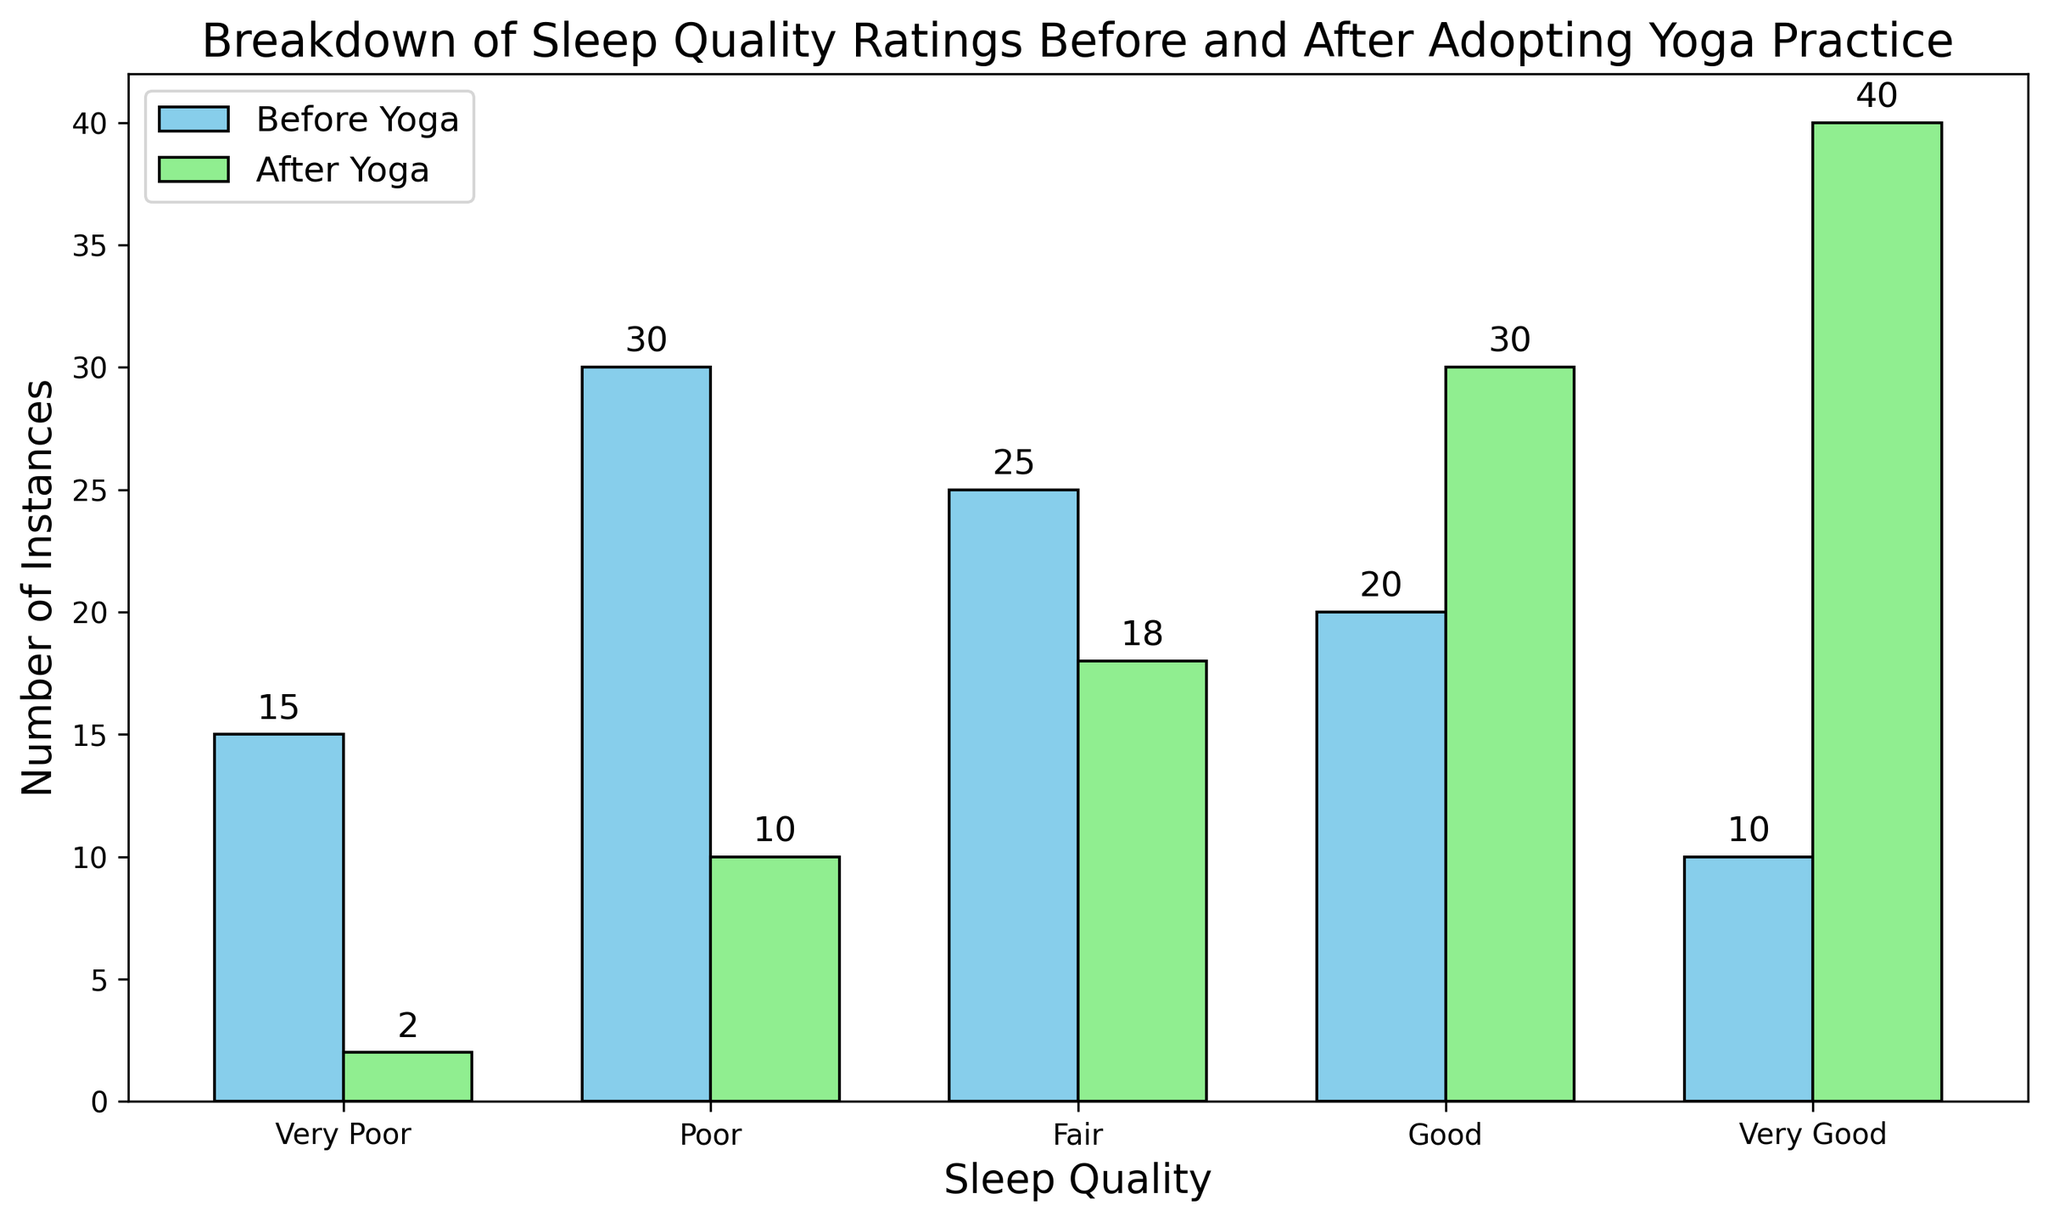What is the total number of instances for "Very Poor" sleep quality before and after adopting yoga? Add the instances for "Very Poor" sleep quality before and after yoga. Before yoga: 15, After yoga: 2, so 15 + 2 = 17
Answer: 17 Which sleep quality rating saw the highest increase in the number of instances after adopting yoga? Compare the increase in each sleep quality rating from before to after practicing yoga. "Very Poor" decreased from 15 to 2 (decrease), "Poor" from 30 to 10 (decrease), "Fair" from 25 to 18 (decrease), "Good" from 20 to 30 (increase of 10), "Very Good" from 10 to 40 (increase of 30). Thus, "Very Good" saw the highest increase.
Answer: Very Good What is the difference in the number of "Poor" sleep quality instances before and after adopting yoga? Subtract the instances after yoga from the instances before yoga for "Poor" sleep quality. Before yoga: 30, After yoga: 10, so 30 - 10 = 20
Answer: 20 Which sleep quality category had more instances after adopting yoga compared to before adopting yoga? Compare the number of instances in each category before and after practicing yoga. Only "Good" and "Very Good" categories have more instances after: Good (30 > 20) and Very Good (40 > 10)
Answer: Good, Very Good How many instances are there combined for "Good" and "Very Good" sleep quality after adopting yoga? Add the instances for "Good" and "Very Good" sleep quality after yoga. Good: 30, Very Good: 40, so 30 + 40 = 70
Answer: 70 Which color represents the "After Yoga" data in the bar chart? Observe the colors of the bars for the instances after yoga. The "After Yoga" bars are represented in light green.
Answer: Light Green 